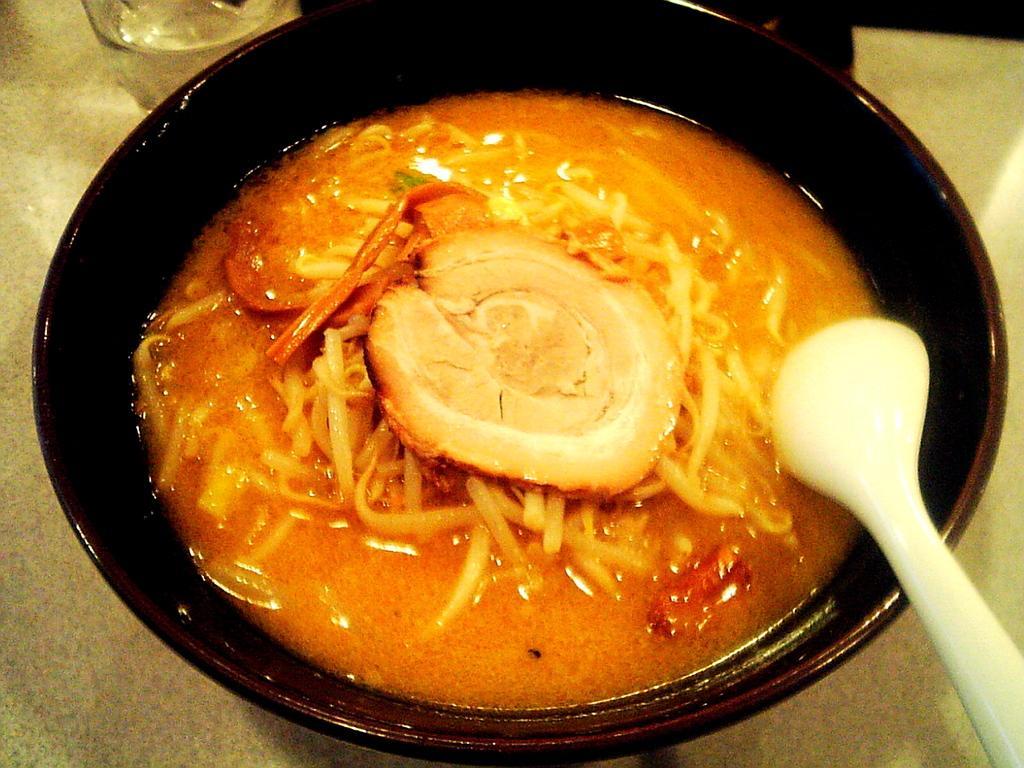Can you describe this image briefly? In the image we can see a bowl, black in color. In the bowl there is a food item. This is a spoon, white in color and a glass. 